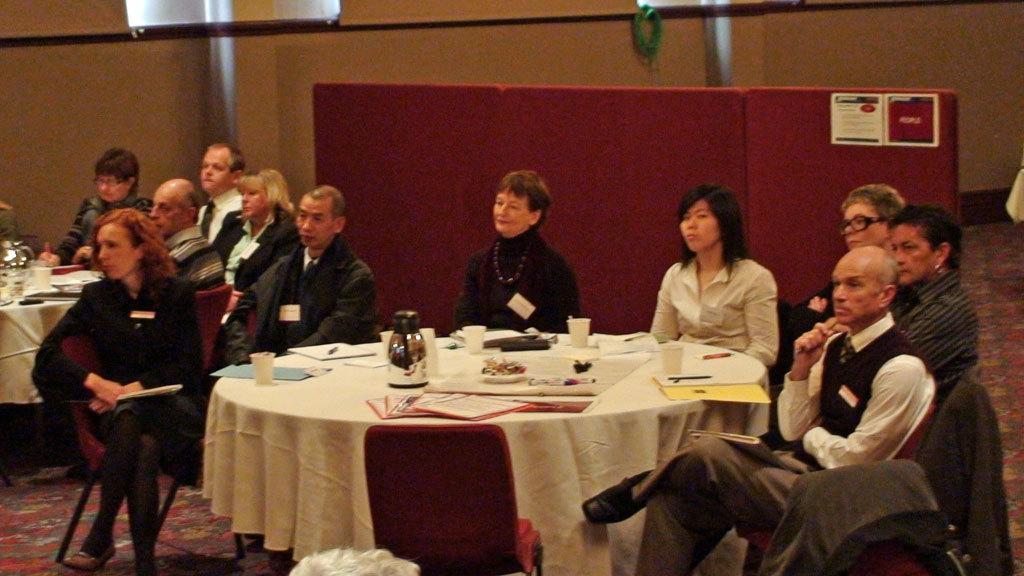Please provide a concise description of this image. This image consists of tables, chairs, people. On the table there is a kettle, papers, books, cups, mobile phones. People are sitting on chair round tables. 